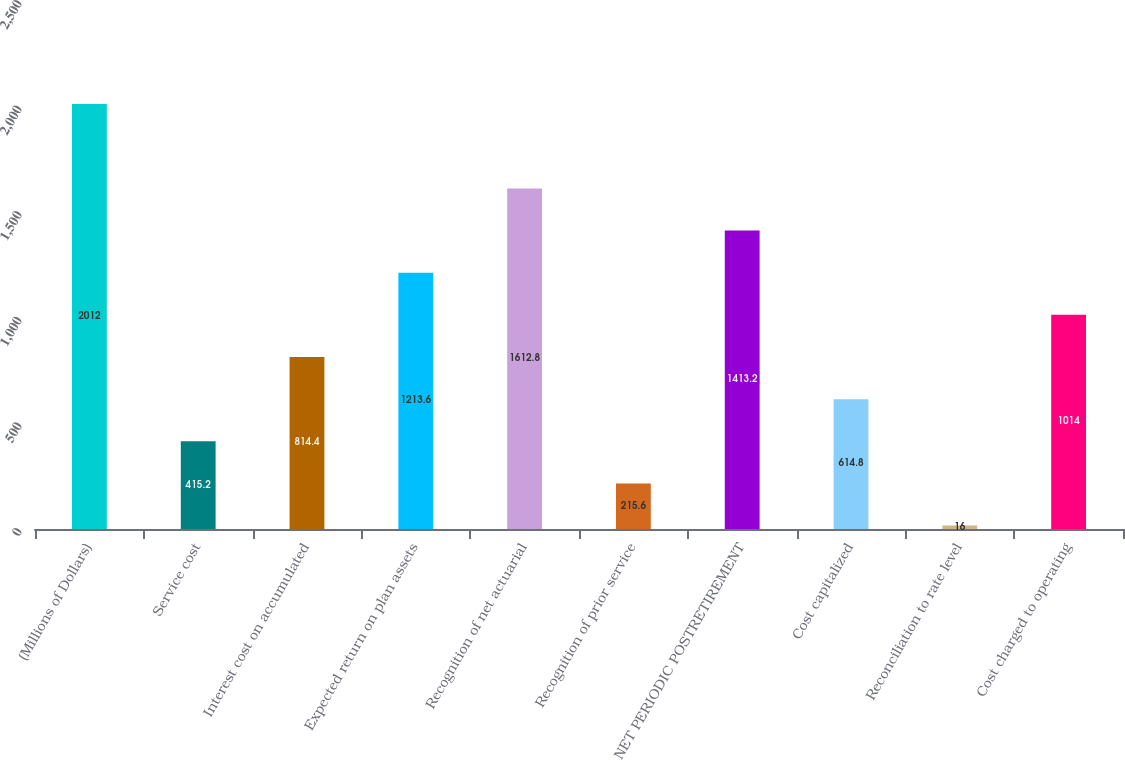<chart> <loc_0><loc_0><loc_500><loc_500><bar_chart><fcel>(Millions of Dollars)<fcel>Service cost<fcel>Interest cost on accumulated<fcel>Expected return on plan assets<fcel>Recognition of net actuarial<fcel>Recognition of prior service<fcel>NET PERIODIC POSTRETIREMENT<fcel>Cost capitalized<fcel>Reconciliation to rate level<fcel>Cost charged to operating<nl><fcel>2012<fcel>415.2<fcel>814.4<fcel>1213.6<fcel>1612.8<fcel>215.6<fcel>1413.2<fcel>614.8<fcel>16<fcel>1014<nl></chart> 